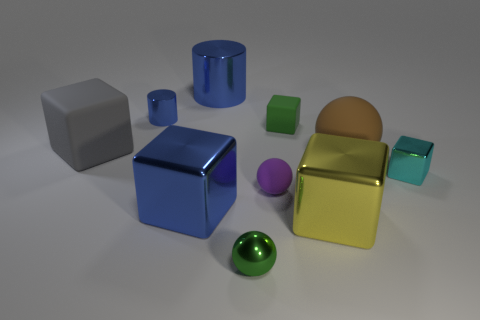Does the large metallic cube that is on the left side of the tiny purple object have the same color as the metal cylinder that is on the right side of the blue metal cube? The large metallic cube on the left side of the picture, which is adjacent to the small purple object, appears to be silver in color. Similarly, the metal cylinder positioned on the right side of the blue metallic cube also exhibits a silver hue. Consequently, both objects share the same color. 